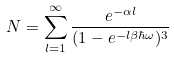Convert formula to latex. <formula><loc_0><loc_0><loc_500><loc_500>N = \sum _ { l = 1 } ^ { \infty } \frac { e ^ { - \alpha l } } { ( 1 - e ^ { - l \beta \hbar { \omega } } ) ^ { 3 } }</formula> 